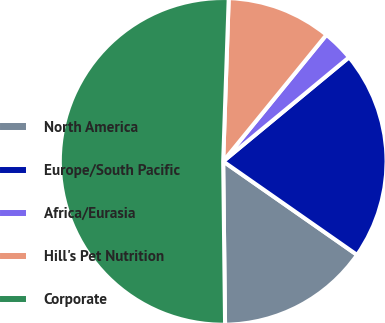Convert chart to OTSL. <chart><loc_0><loc_0><loc_500><loc_500><pie_chart><fcel>North America<fcel>Europe/South Pacific<fcel>Africa/Eurasia<fcel>Hill's Pet Nutrition<fcel>Corporate<nl><fcel>15.11%<fcel>20.7%<fcel>3.11%<fcel>10.35%<fcel>50.72%<nl></chart> 